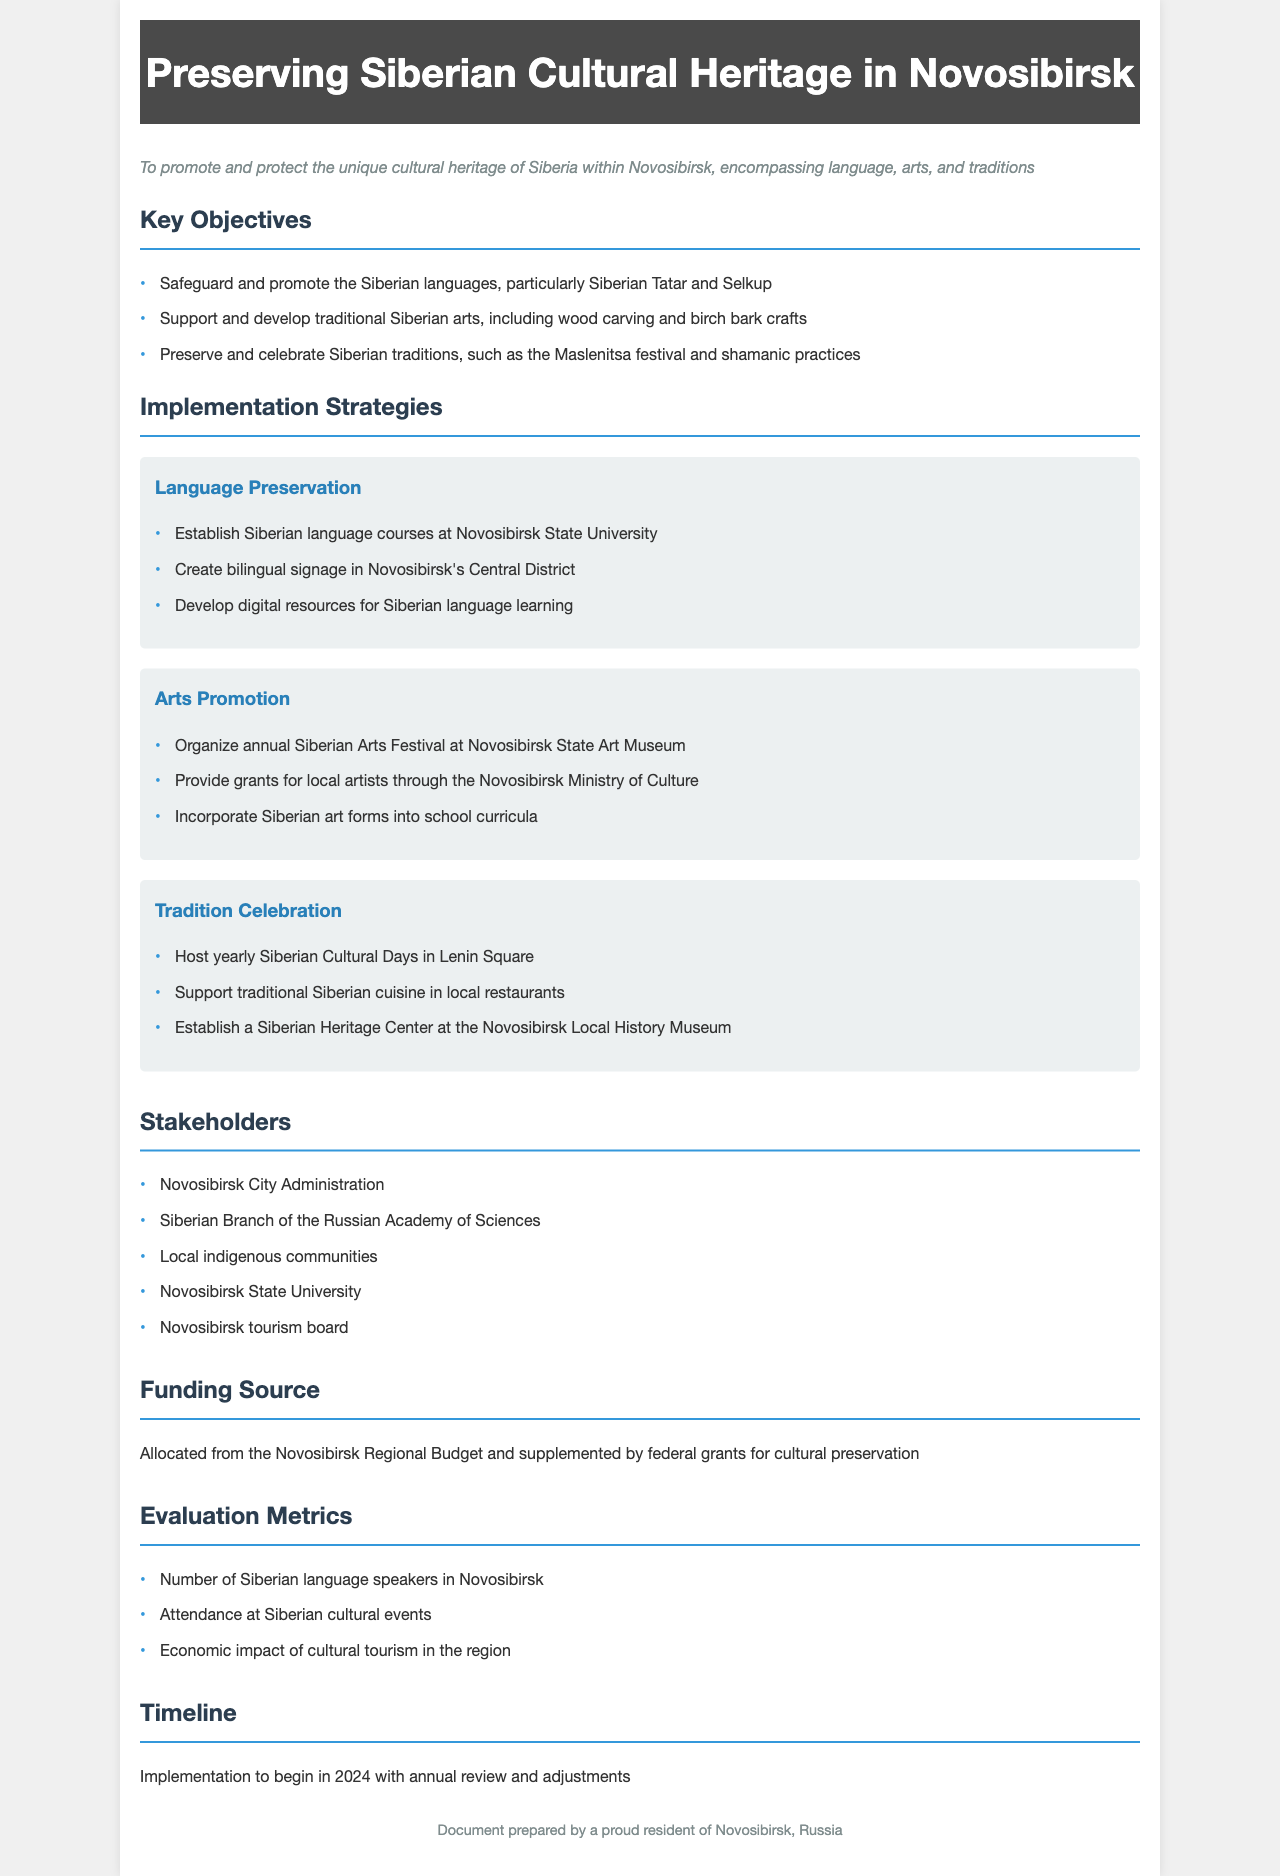What is the primary purpose of the document? The primary purpose is stated in the document's purpose section, which expresses the aim to promote and protect cultural heritage.
Answer: To promote and protect the unique cultural heritage of Siberia within Novosibirsk, encompassing language, arts, and traditions Which languages are specifically mentioned for preservation? The document lists specific languages aimed for preservation under the key objectives section.
Answer: Siberian Tatar and Selkup What annual event is organized to support traditional arts? The document outlines an annual event in the arts promotion strategy to highlight traditional Siberian arts.
Answer: Siberian Arts Festival Who are the local stakeholders involved? The stakeholders are listed under the stakeholders section, providing key entities involved in the policy framework.
Answer: Novosibirsk City Administration, Siberian Branch of the Russian Academy of Sciences, Local indigenous communities, Novosibirsk State University, Novosibirsk tourism board What is the timeline for implementing the policy? The implementation timeline is specified in the timeline section, indicating when actions will begin and how often they will be reviewed.
Answer: 2024 with annual review and adjustments What type of funding will be used for this initiative? The funding source is described in the funding section, explaining how the initiative will be financially supported.
Answer: Allocated from the Novosibirsk Regional Budget and supplemented by federal grants for cultural preservation What is one metric used to evaluate the policy's impact? The evaluation metrics include specific measures outlined in the evaluation section, indicating how effectiveness will be assessed.
Answer: Number of Siberian language speakers in Novosibirsk 